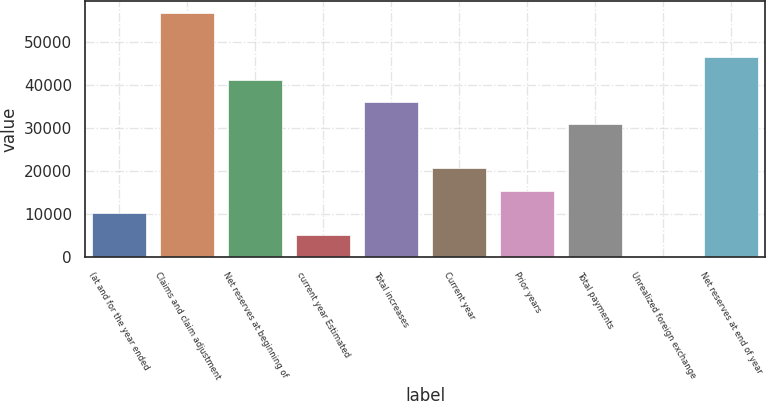Convert chart. <chart><loc_0><loc_0><loc_500><loc_500><bar_chart><fcel>(at and for the year ended<fcel>Claims and claim adjustment<fcel>Net reserves at beginning of<fcel>current year Estimated<fcel>Total increases<fcel>Current year<fcel>Prior years<fcel>Total payments<fcel>Unrealized foreign exchange<fcel>Net reserves at end of year<nl><fcel>10329<fcel>56688<fcel>41235<fcel>5178<fcel>36084<fcel>20631<fcel>15480<fcel>30933<fcel>27<fcel>46386<nl></chart> 